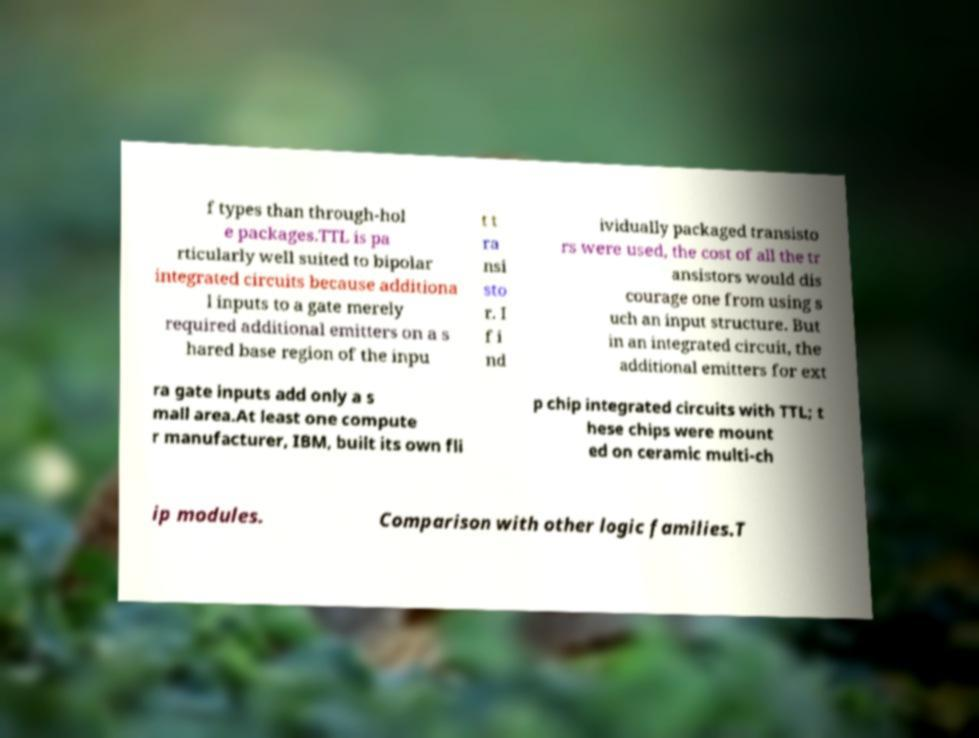There's text embedded in this image that I need extracted. Can you transcribe it verbatim? f types than through-hol e packages.TTL is pa rticularly well suited to bipolar integrated circuits because additiona l inputs to a gate merely required additional emitters on a s hared base region of the inpu t t ra nsi sto r. I f i nd ividually packaged transisto rs were used, the cost of all the tr ansistors would dis courage one from using s uch an input structure. But in an integrated circuit, the additional emitters for ext ra gate inputs add only a s mall area.At least one compute r manufacturer, IBM, built its own fli p chip integrated circuits with TTL; t hese chips were mount ed on ceramic multi-ch ip modules. Comparison with other logic families.T 